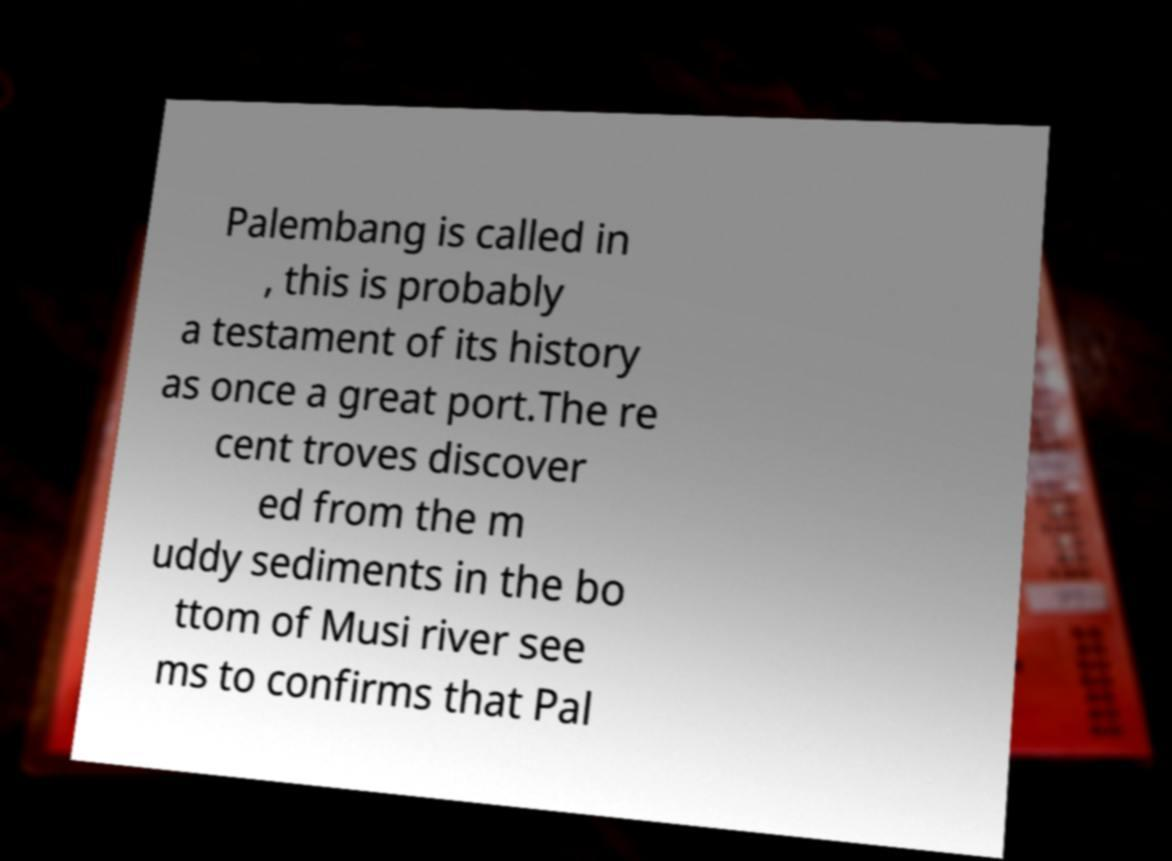Can you read and provide the text displayed in the image?This photo seems to have some interesting text. Can you extract and type it out for me? Palembang is called in , this is probably a testament of its history as once a great port.The re cent troves discover ed from the m uddy sediments in the bo ttom of Musi river see ms to confirms that Pal 